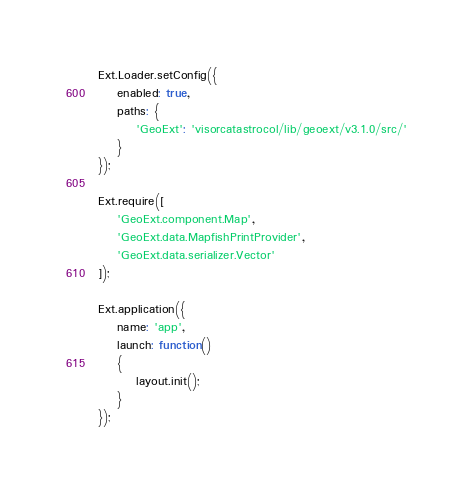Convert code to text. <code><loc_0><loc_0><loc_500><loc_500><_JavaScript_>
Ext.Loader.setConfig({
	enabled: true,
	paths: {
		'GeoExt': 'visorcatastrocol/lib/geoext/v3.1.0/src/'
	}
});

Ext.require([
	'GeoExt.component.Map',
	'GeoExt.data.MapfishPrintProvider',
	'GeoExt.data.serializer.Vector'
]);

Ext.application({
    name: 'app',
    launch: function()
    {         		   			      
		layout.init();
    } 
});</code> 